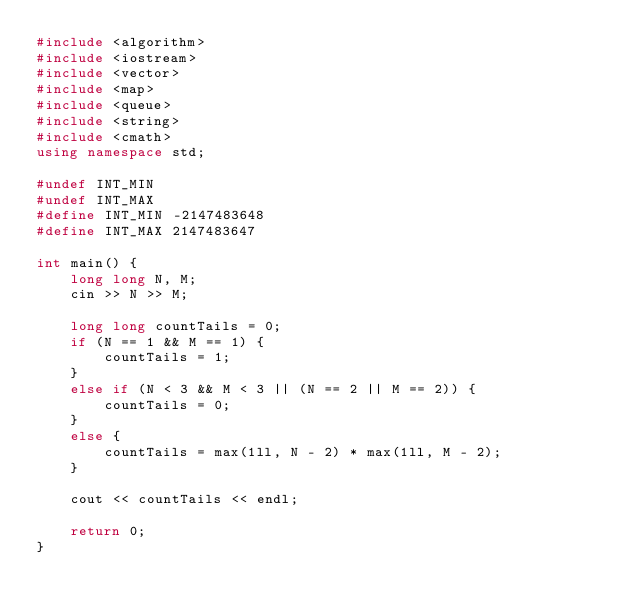<code> <loc_0><loc_0><loc_500><loc_500><_C++_>#include <algorithm>
#include <iostream>
#include <vector>
#include <map>
#include <queue>
#include <string>
#include <cmath>
using namespace std;

#undef INT_MIN
#undef INT_MAX
#define INT_MIN -2147483648
#define INT_MAX 2147483647

int main() {
	long long N, M;
	cin >> N >> M;

	long long countTails = 0;
	if (N == 1 && M == 1) {
		countTails = 1;
	}
	else if (N < 3 && M < 3 || (N == 2 || M == 2)) {
		countTails = 0;
	}
	else {
		countTails = max(1ll, N - 2) * max(1ll, M - 2);
	}

	cout << countTails << endl;

	return 0;
}</code> 